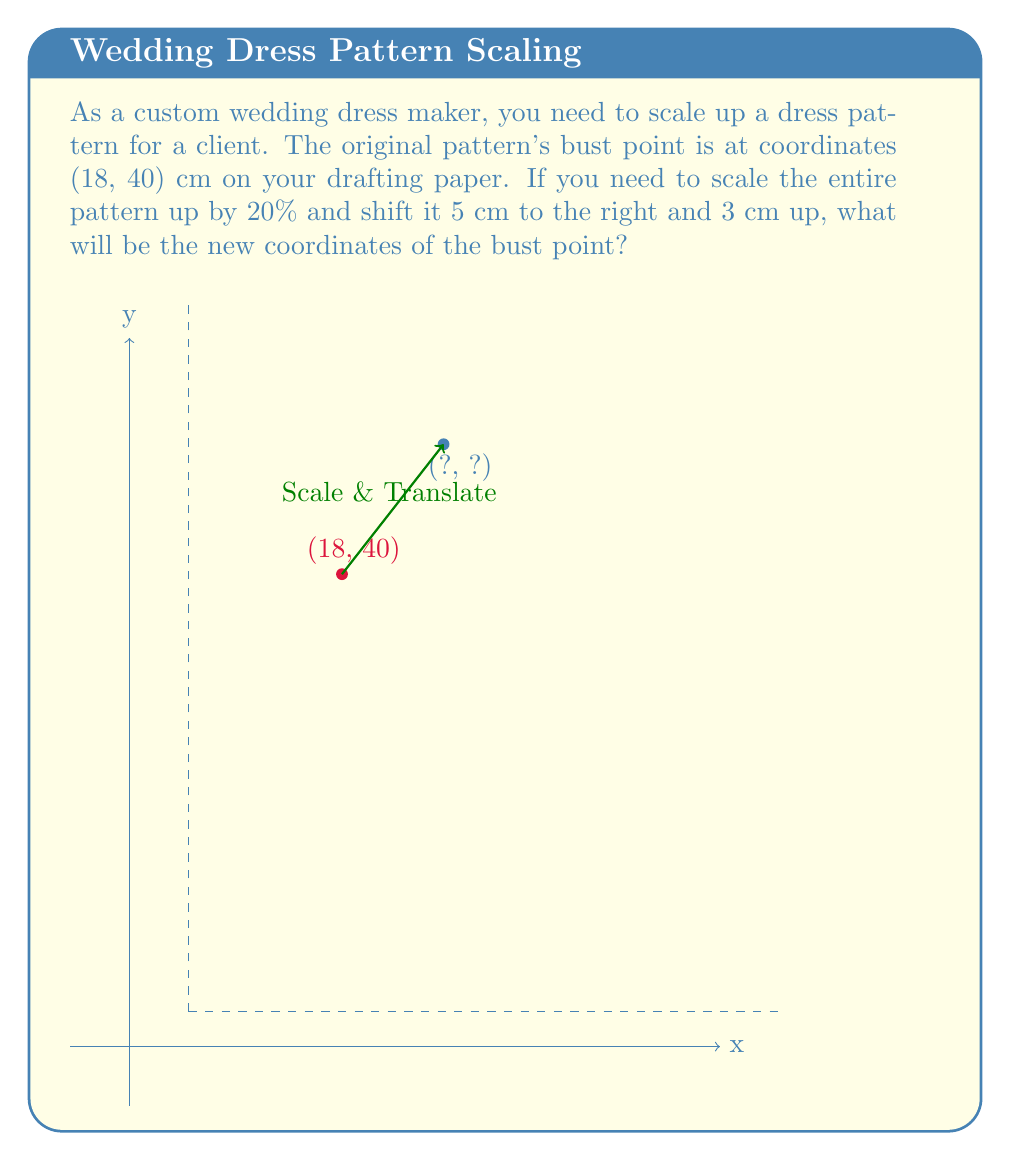Can you answer this question? To solve this problem, we'll follow these steps:

1) First, let's apply the scaling transformation:
   - Scaling by 20% means multiplying the coordinates by 1.2
   - For x: $18 \times 1.2 = 21.6$ cm
   - For y: $40 \times 1.2 = 48$ cm

2) Now, we apply the translation:
   - Shift 5 cm to the right: Add 5 to the x-coordinate
   - Shift 3 cm up: Add 3 to the y-coordinate

   For x: $21.6 + 5 = 26.6$ cm
   For y: $48 + 3 = 51$ cm

3) Therefore, the new coordinates are (26.6, 51) cm

We can express this transformation mathematically as:

$$\begin{pmatrix} x' \\ y' \end{pmatrix} = 1.2 \begin{pmatrix} x \\ y \end{pmatrix} + \begin{pmatrix} 5 \\ 3 \end{pmatrix}$$

Where $(x, y)$ are the original coordinates and $(x', y')$ are the new coordinates.
Answer: (26.6, 51) cm 